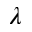<formula> <loc_0><loc_0><loc_500><loc_500>\lambda</formula> 